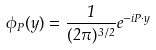Convert formula to latex. <formula><loc_0><loc_0><loc_500><loc_500>\phi _ { P } ( y ) = \frac { 1 } { ( 2 \pi ) ^ { 3 / 2 } } e ^ { - i P \cdot y }</formula> 